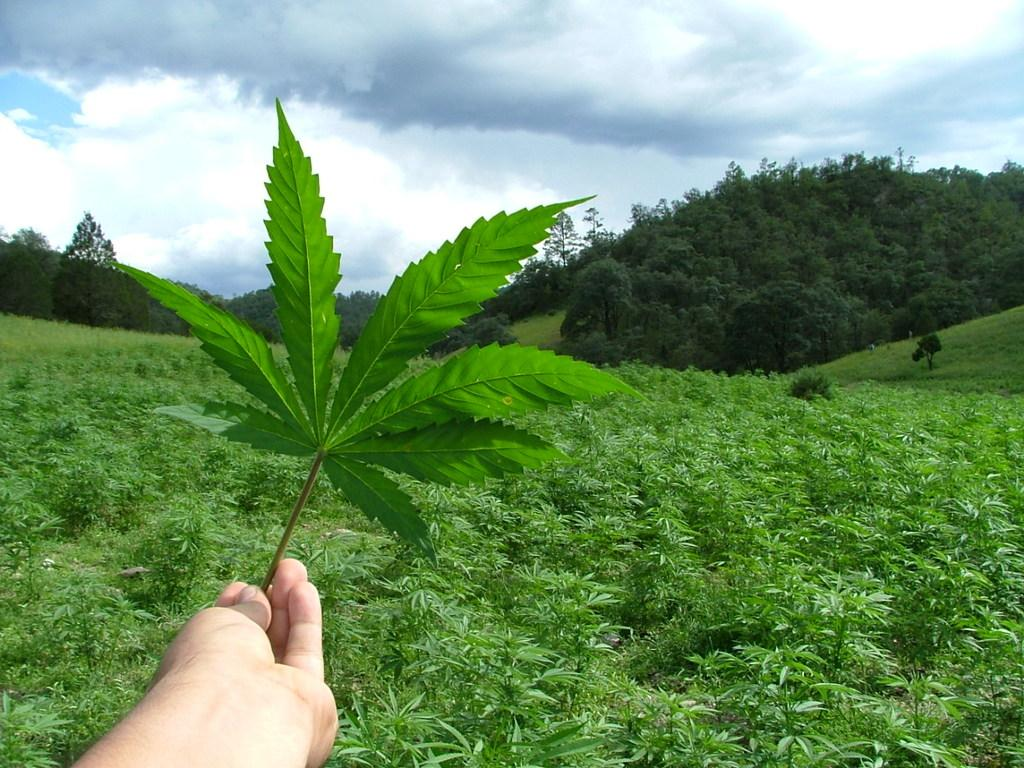What is the person holding in their hand in the image? There is a plant in a person's hand in the image. What can be seen in the background of the image? The sky is visible in the background of the image. Where is the chair located in the image? There is no chair present in the image. What type of glue is being used to attach the plant to the person's hand in the image? There is no glue present in the image, and the plant is simply being held by the person. 